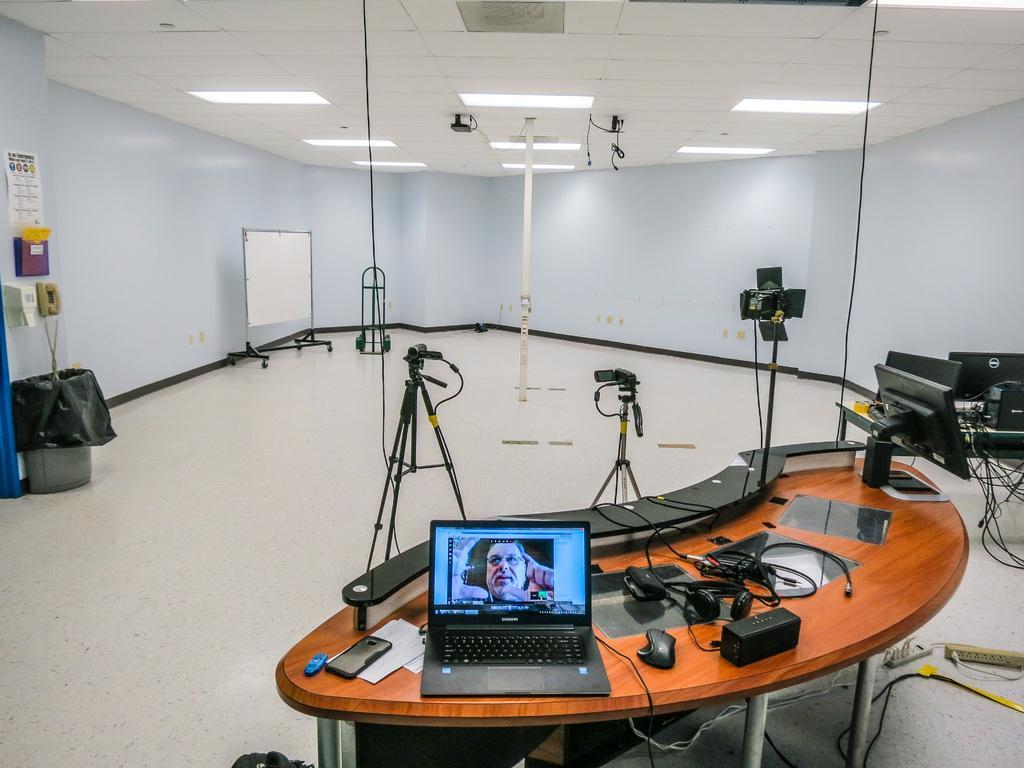Can you describe this image briefly? In this image we can see a table containing a laptop, cellphone, papers, remote, mouse, a monitor and some wires. We can also see some cameras with stand on the floor. On the left side we can see a dustbin, and tissue paper holder, a telephone and some papers pasted on a wall. On the backside we can see a board, pole and a roof with some ceiling lights. 